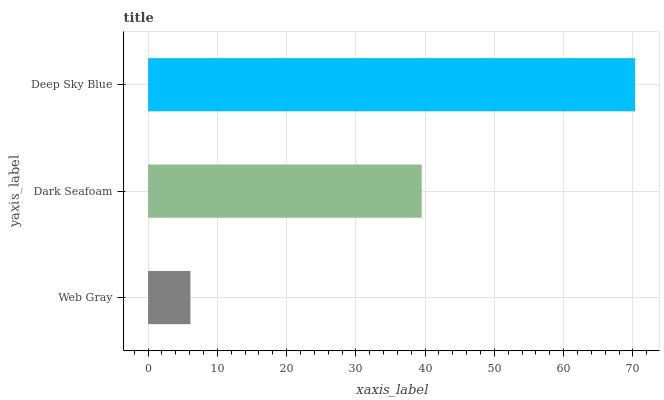Is Web Gray the minimum?
Answer yes or no. Yes. Is Deep Sky Blue the maximum?
Answer yes or no. Yes. Is Dark Seafoam the minimum?
Answer yes or no. No. Is Dark Seafoam the maximum?
Answer yes or no. No. Is Dark Seafoam greater than Web Gray?
Answer yes or no. Yes. Is Web Gray less than Dark Seafoam?
Answer yes or no. Yes. Is Web Gray greater than Dark Seafoam?
Answer yes or no. No. Is Dark Seafoam less than Web Gray?
Answer yes or no. No. Is Dark Seafoam the high median?
Answer yes or no. Yes. Is Dark Seafoam the low median?
Answer yes or no. Yes. Is Web Gray the high median?
Answer yes or no. No. Is Deep Sky Blue the low median?
Answer yes or no. No. 